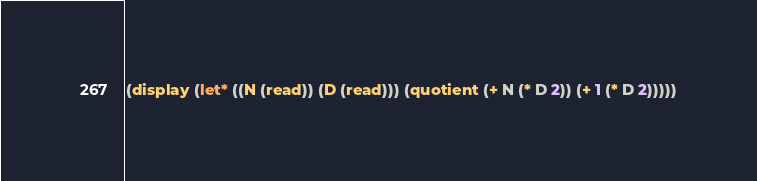<code> <loc_0><loc_0><loc_500><loc_500><_Scheme_>(display (let* ((N (read)) (D (read))) (quotient (+ N (* D 2)) (+ 1 (* D 2)))))</code> 